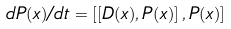<formula> <loc_0><loc_0><loc_500><loc_500>d P ( x ) / d t = \left [ \left [ D ( x ) , P ( x ) \right ] , P ( x ) \right ]</formula> 